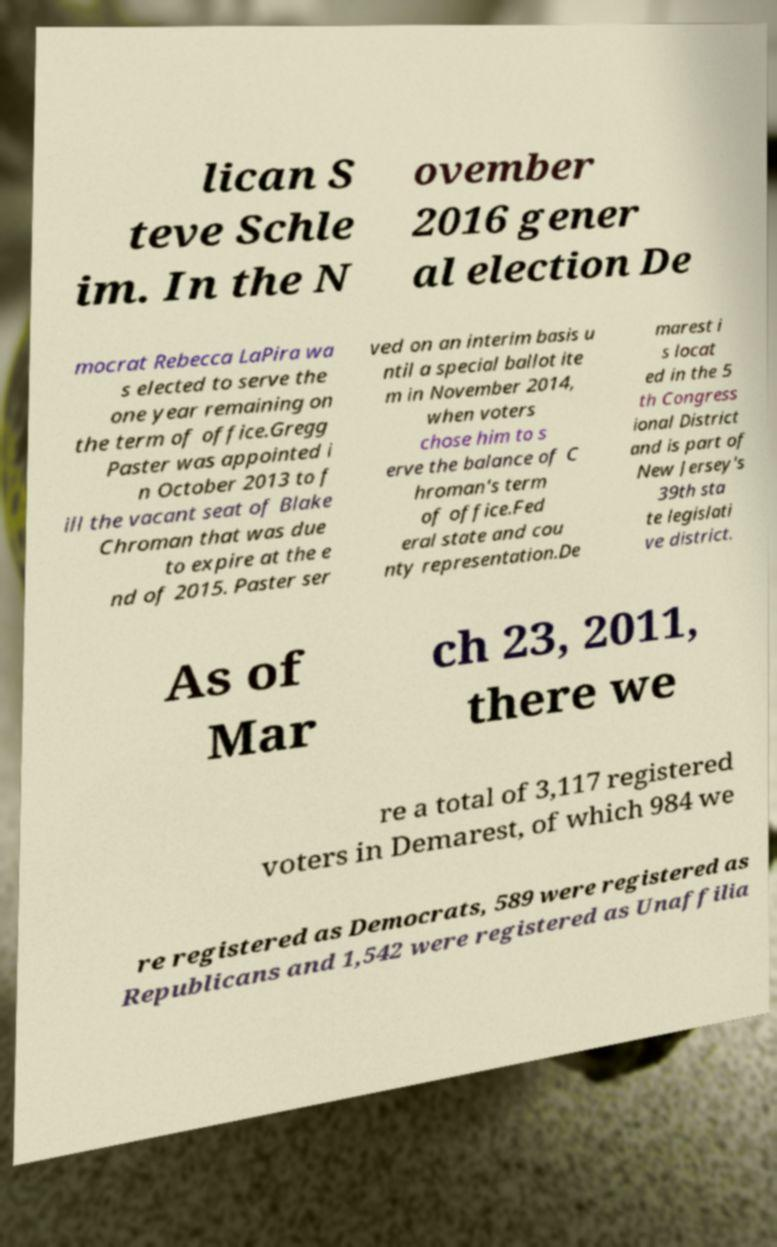For documentation purposes, I need the text within this image transcribed. Could you provide that? lican S teve Schle im. In the N ovember 2016 gener al election De mocrat Rebecca LaPira wa s elected to serve the one year remaining on the term of office.Gregg Paster was appointed i n October 2013 to f ill the vacant seat of Blake Chroman that was due to expire at the e nd of 2015. Paster ser ved on an interim basis u ntil a special ballot ite m in November 2014, when voters chose him to s erve the balance of C hroman's term of office.Fed eral state and cou nty representation.De marest i s locat ed in the 5 th Congress ional District and is part of New Jersey's 39th sta te legislati ve district. As of Mar ch 23, 2011, there we re a total of 3,117 registered voters in Demarest, of which 984 we re registered as Democrats, 589 were registered as Republicans and 1,542 were registered as Unaffilia 